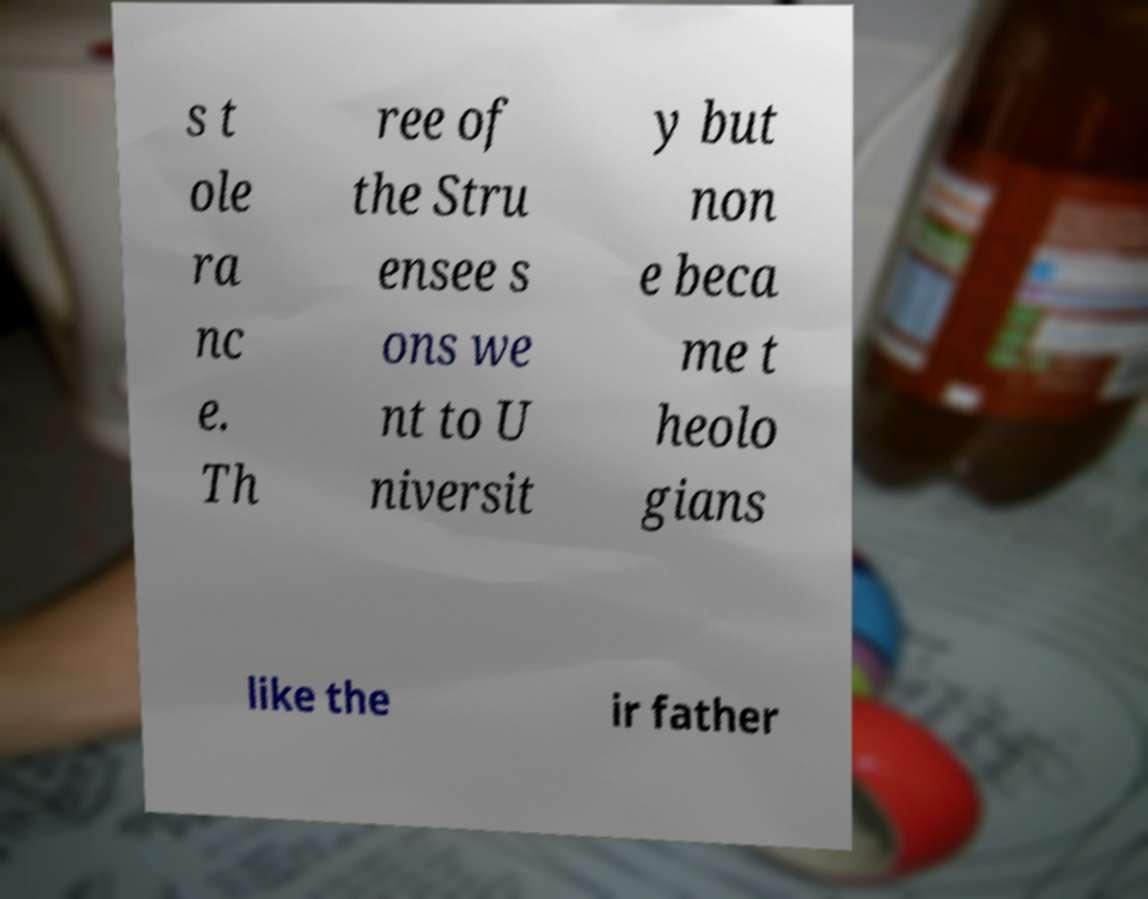Can you accurately transcribe the text from the provided image for me? s t ole ra nc e. Th ree of the Stru ensee s ons we nt to U niversit y but non e beca me t heolo gians like the ir father 